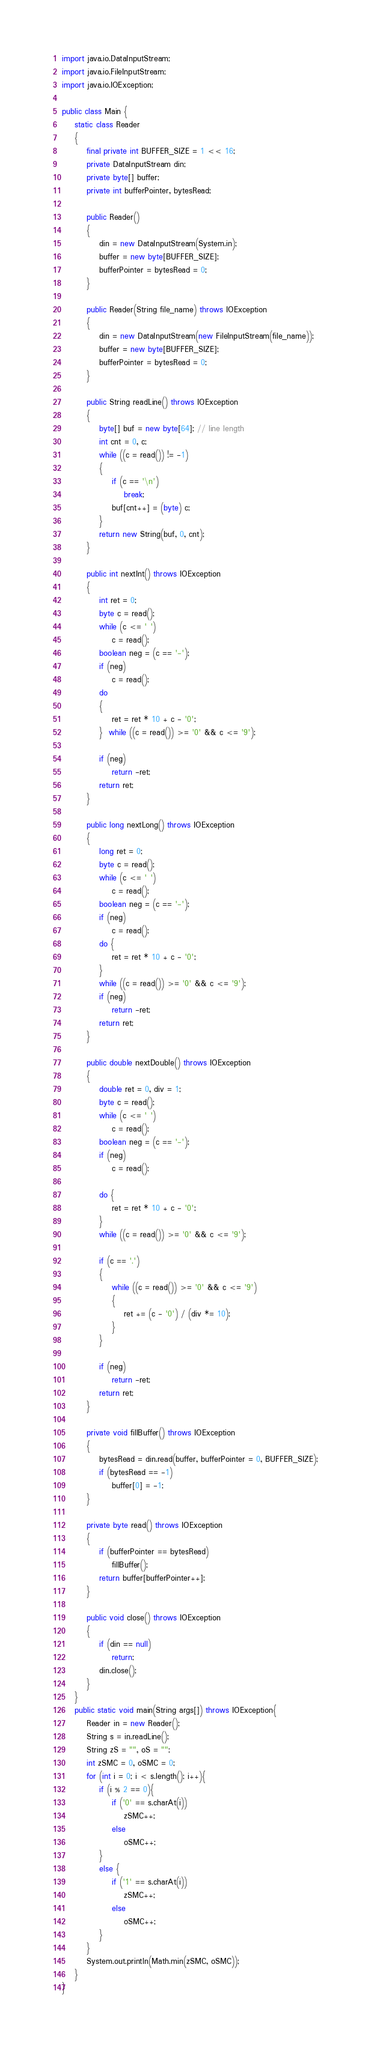Convert code to text. <code><loc_0><loc_0><loc_500><loc_500><_Java_>import java.io.DataInputStream;
import java.io.FileInputStream;
import java.io.IOException;

public class Main {
    static class Reader
    {
        final private int BUFFER_SIZE = 1 << 16;
        private DataInputStream din;
        private byte[] buffer;
        private int bufferPointer, bytesRead;

        public Reader()
        {
            din = new DataInputStream(System.in);
            buffer = new byte[BUFFER_SIZE];
            bufferPointer = bytesRead = 0;
        }

        public Reader(String file_name) throws IOException
        {
            din = new DataInputStream(new FileInputStream(file_name));
            buffer = new byte[BUFFER_SIZE];
            bufferPointer = bytesRead = 0;
        }

        public String readLine() throws IOException
        {
            byte[] buf = new byte[64]; // line length
            int cnt = 0, c;
            while ((c = read()) != -1)
            {
                if (c == '\n')
                    break;
                buf[cnt++] = (byte) c;
            }
            return new String(buf, 0, cnt);
        }

        public int nextInt() throws IOException
        {
            int ret = 0;
            byte c = read();
            while (c <= ' ')
                c = read();
            boolean neg = (c == '-');
            if (neg)
                c = read();
            do
            {
                ret = ret * 10 + c - '0';
            }  while ((c = read()) >= '0' && c <= '9');

            if (neg)
                return -ret;
            return ret;
        }

        public long nextLong() throws IOException
        {
            long ret = 0;
            byte c = read();
            while (c <= ' ')
                c = read();
            boolean neg = (c == '-');
            if (neg)
                c = read();
            do {
                ret = ret * 10 + c - '0';
            }
            while ((c = read()) >= '0' && c <= '9');
            if (neg)
                return -ret;
            return ret;
        }

        public double nextDouble() throws IOException
        {
            double ret = 0, div = 1;
            byte c = read();
            while (c <= ' ')
                c = read();
            boolean neg = (c == '-');
            if (neg)
                c = read();

            do {
                ret = ret * 10 + c - '0';
            }
            while ((c = read()) >= '0' && c <= '9');

            if (c == '.')
            {
                while ((c = read()) >= '0' && c <= '9')
                {
                    ret += (c - '0') / (div *= 10);
                }
            }

            if (neg)
                return -ret;
            return ret;
        }

        private void fillBuffer() throws IOException
        {
            bytesRead = din.read(buffer, bufferPointer = 0, BUFFER_SIZE);
            if (bytesRead == -1)
                buffer[0] = -1;
        }

        private byte read() throws IOException
        {
            if (bufferPointer == bytesRead)
                fillBuffer();
            return buffer[bufferPointer++];
        }

        public void close() throws IOException
        {
            if (din == null)
                return;
            din.close();
        }
    }
    public static void main(String args[]) throws IOException{
        Reader in = new Reader();
        String s = in.readLine();
        String zS = "", oS = "";
        int zSMC = 0, oSMC = 0;
        for (int i = 0; i < s.length(); i++){
            if (i % 2 == 0){
                if ('0' == s.charAt(i))
                    zSMC++;
                else
                    oSMC++;
            }
            else {
                if ('1' == s.charAt(i))
                    zSMC++;
                else
                    oSMC++;
            }
        }
        System.out.println(Math.min(zSMC, oSMC));
    }
}
</code> 